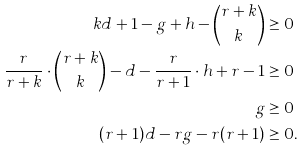Convert formula to latex. <formula><loc_0><loc_0><loc_500><loc_500>k d + 1 - g + h - \binom { r + k } { k } & \geq 0 \\ \frac { r } { r + k } \cdot \binom { r + k } { k } - d - \frac { r } { r + 1 } \cdot h + r - 1 & \geq 0 \\ g & \geq 0 \\ ( r + 1 ) d - r g - r ( r + 1 ) & \geq 0 .</formula> 